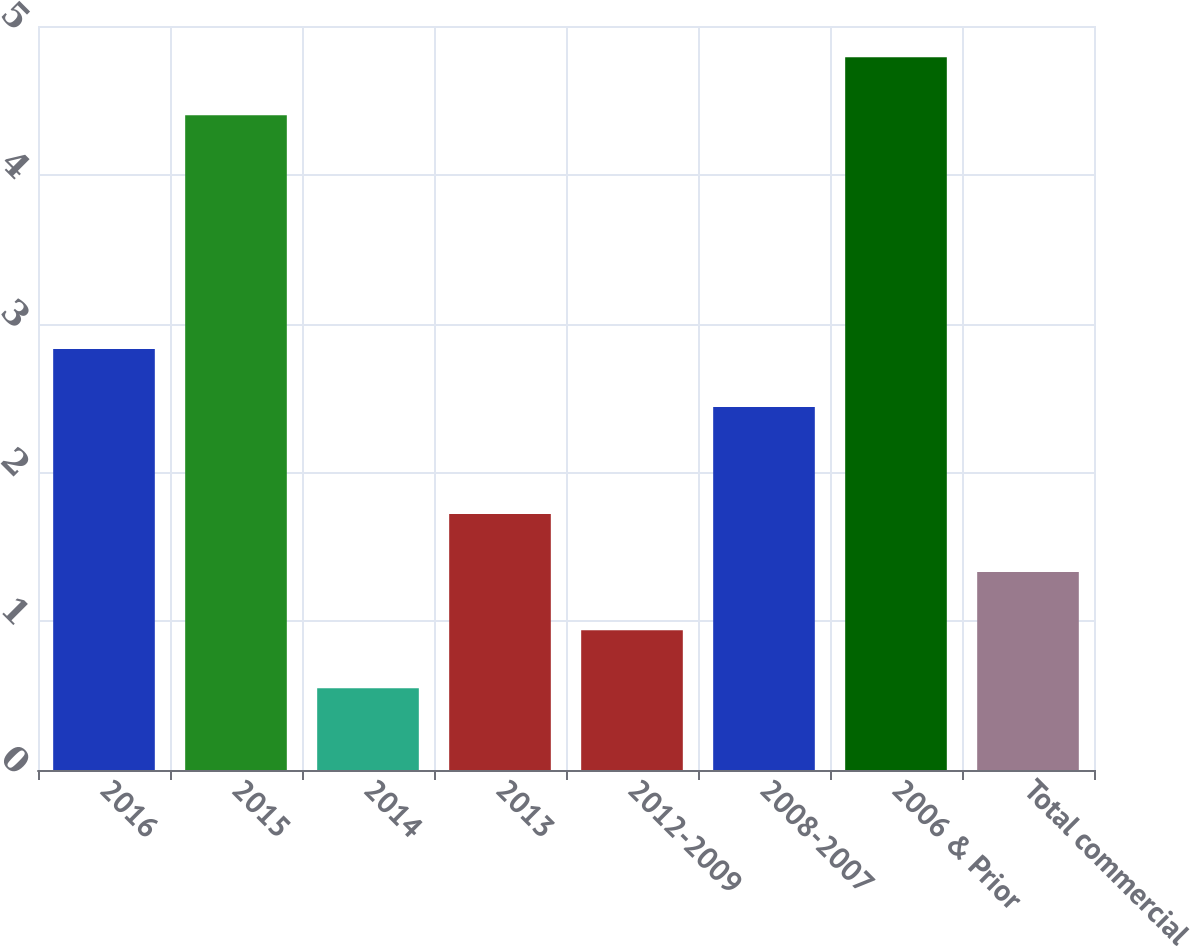Convert chart. <chart><loc_0><loc_0><loc_500><loc_500><bar_chart><fcel>2016<fcel>2015<fcel>2014<fcel>2013<fcel>2012-2009<fcel>2008-2007<fcel>2006 & Prior<fcel>Total commercial<nl><fcel>2.83<fcel>4.4<fcel>0.55<fcel>1.72<fcel>0.94<fcel>2.44<fcel>4.79<fcel>1.33<nl></chart> 